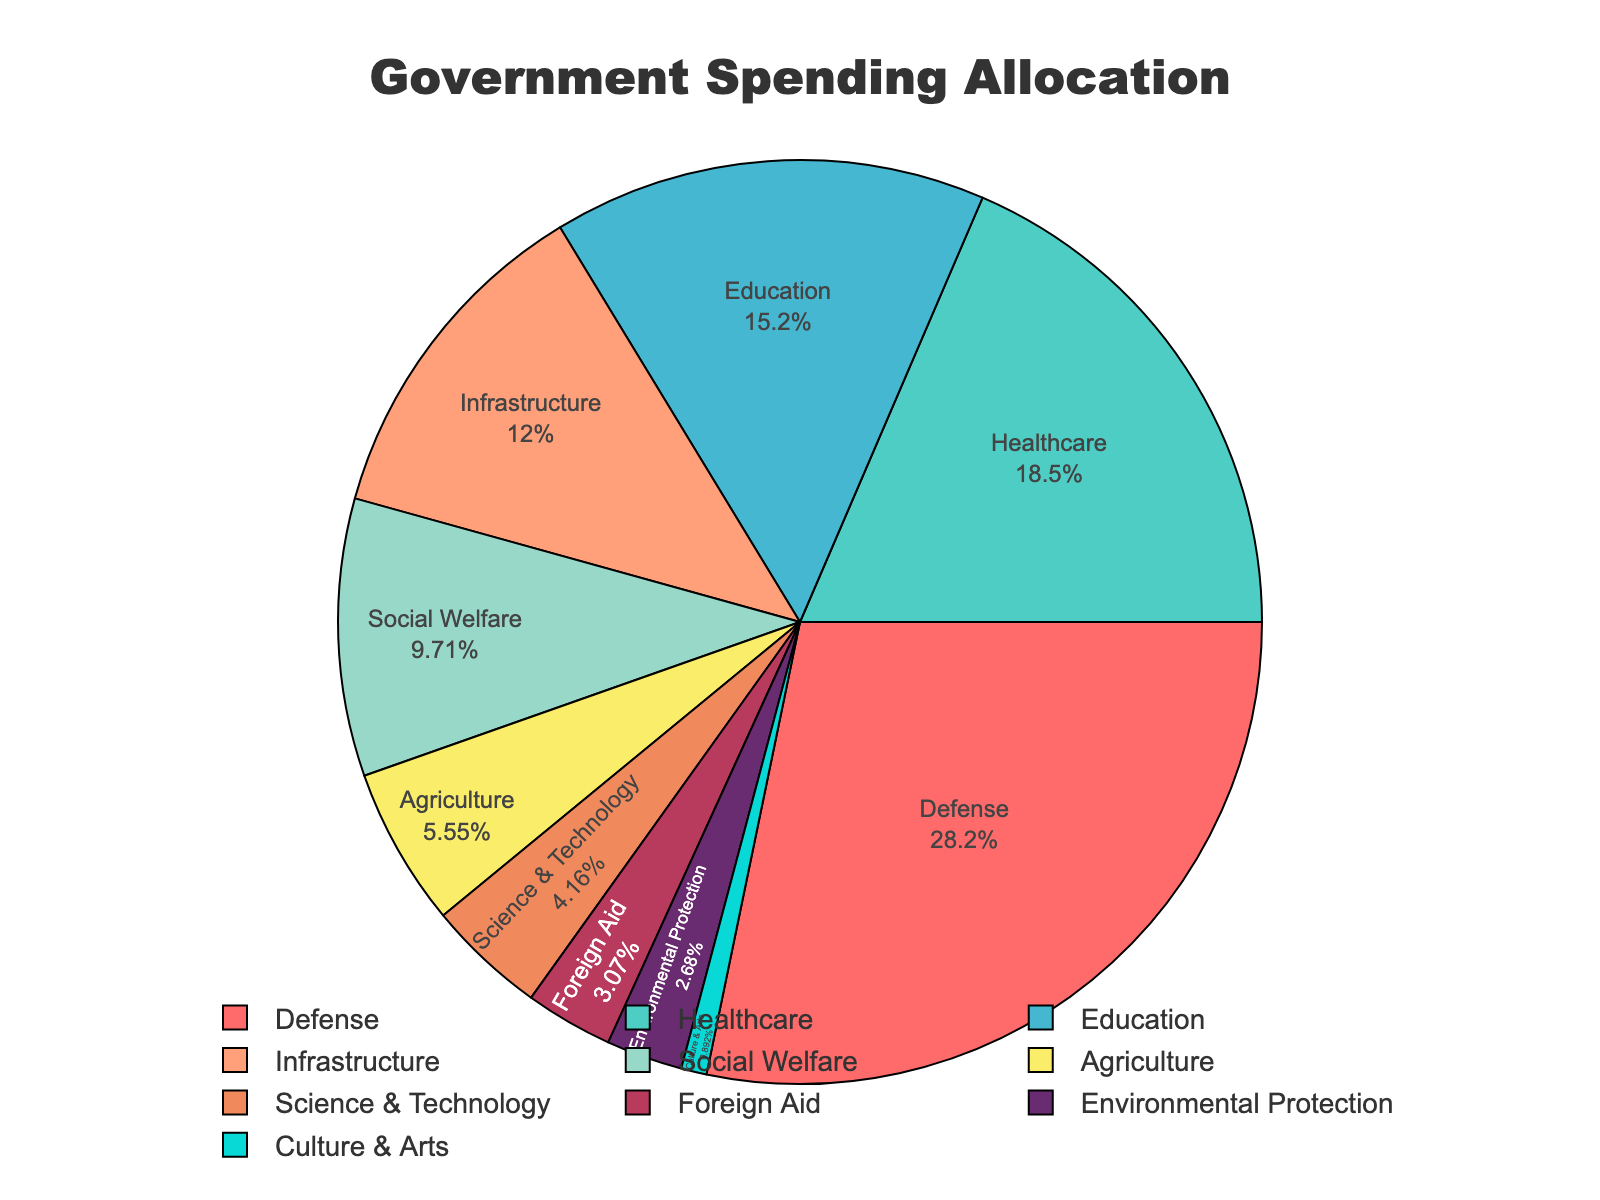What's the total percentage of government spending allocated to Healthcare, Education, and Infrastructure combined? To find the total percentage, sum up the individual percentages for Healthcare, Education, and Infrastructure: 18.7 + 15.3 + 12.1 = 46.1%
Answer: 46.1% Which sector received the highest percentage allocation? Simply look at the segment with the largest portion of the pie chart's data. The Defense sector has the largest slice at 28.5%.
Answer: Defense How much more is spent on Defense compared to Social Welfare? Subtract the percentage for Social Welfare from the percentage for Defense: 28.5 - 9.8 = 18.7%
Answer: 18.7% What is the percentage difference between Agriculture and Science & Technology? Subtract the percentage for Science & Technology from the percentage for Agriculture: 5.6 - 4.2 = 1.4%
Answer: 1.4% Identify the sector that has just over half the allocation percentage compared to the sector with the highest allocation. The sector with the highest allocation is Defense (28.5%). Half of that is 14.25%. The closest sector just over half is Education at 15.3%.
Answer: Education Which sectors combined make up less than 10% of the total spending? Look at the pie chart for sectors with percentages that sum up to less than 10%. These sectors are Foreign Aid (3.1%), Environmental Protection (2.7%), and Culture & Arts (0.9%): 3.1 + 2.7 + 0.9 = 6.7%
Answer: Foreign Aid, Environmental Protection, Culture & Arts How does the allocation for Healthcare compare to that for Agriculture and Science & Technology combined? Sum the percentages for Agriculture and Science & Technology: 5.6 + 4.2 = 9.8%. Compare this to Healthcare's 18.7%. Healthcare receives 8.9% more funding.
Answer: Healthcare receives 8.9% more What is the combined allocation percentage for sectors related to scientific advancement (Science & Technology, Environmental Protection)? Sum up the percentages for Science & Technology and Environmental Protection: 4.2 + 2.7 = 6.9%
Answer: 6.9% Is the percentage for Infrastructure greater than the combined percentage for Foreign Aid and Culture & Arts? Sum the percentages for Foreign Aid and Culture & Arts: 3.1 + 0.9 = 4.0%. Compare this to Infrastructure's 12.1%. Infrastructure is indeed greater.
Answer: Yes 